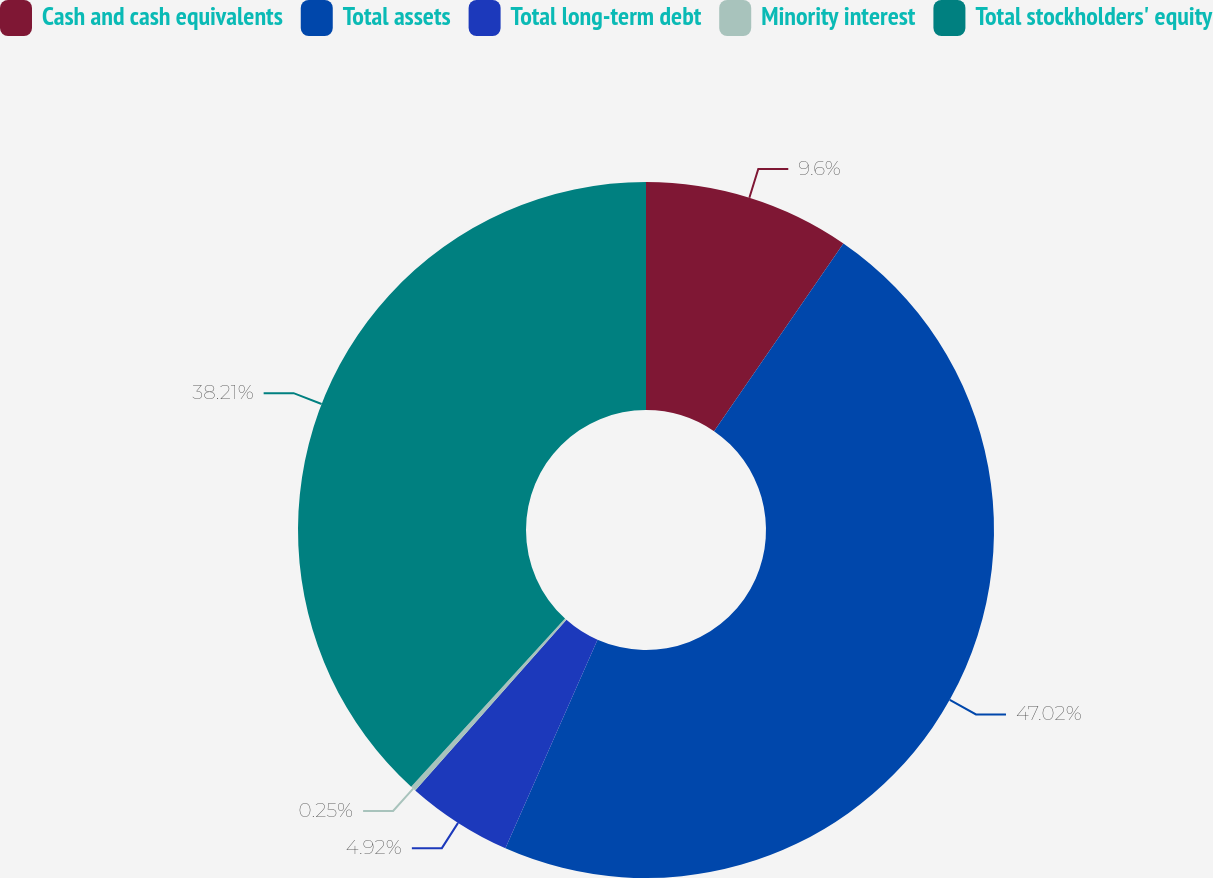Convert chart to OTSL. <chart><loc_0><loc_0><loc_500><loc_500><pie_chart><fcel>Cash and cash equivalents<fcel>Total assets<fcel>Total long-term debt<fcel>Minority interest<fcel>Total stockholders' equity<nl><fcel>9.6%<fcel>47.02%<fcel>4.92%<fcel>0.25%<fcel>38.21%<nl></chart> 